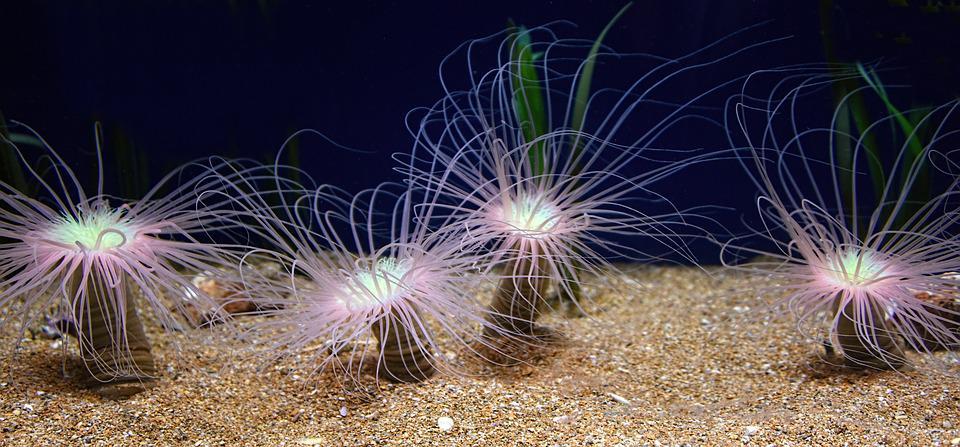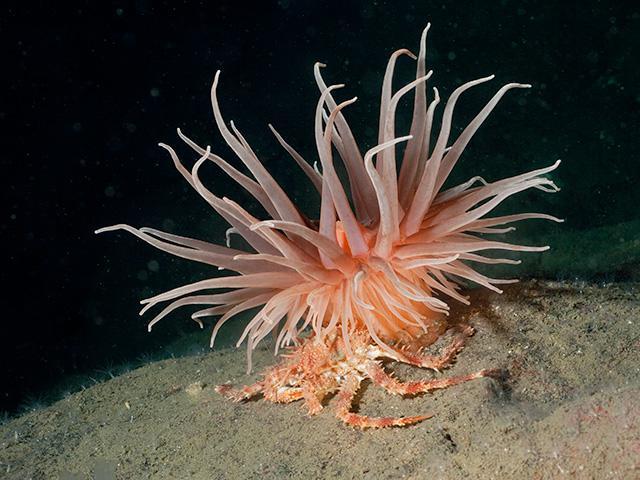The first image is the image on the left, the second image is the image on the right. Given the left and right images, does the statement "One image features a peach-colored anemone with a thick stalk, and the other shows anemone with a black-and-white zebra-look pattern on the stalk." hold true? Answer yes or no. No. The first image is the image on the left, the second image is the image on the right. Given the left and right images, does the statement "There are exactly one sea anemone in each of the images." hold true? Answer yes or no. No. 